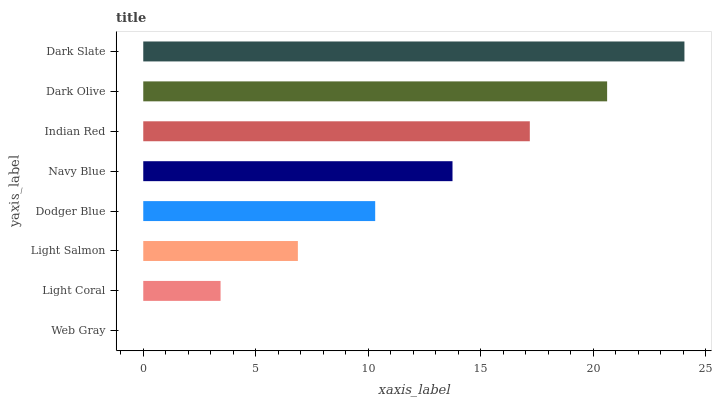Is Web Gray the minimum?
Answer yes or no. Yes. Is Dark Slate the maximum?
Answer yes or no. Yes. Is Light Coral the minimum?
Answer yes or no. No. Is Light Coral the maximum?
Answer yes or no. No. Is Light Coral greater than Web Gray?
Answer yes or no. Yes. Is Web Gray less than Light Coral?
Answer yes or no. Yes. Is Web Gray greater than Light Coral?
Answer yes or no. No. Is Light Coral less than Web Gray?
Answer yes or no. No. Is Navy Blue the high median?
Answer yes or no. Yes. Is Dodger Blue the low median?
Answer yes or no. Yes. Is Dark Olive the high median?
Answer yes or no. No. Is Dark Slate the low median?
Answer yes or no. No. 